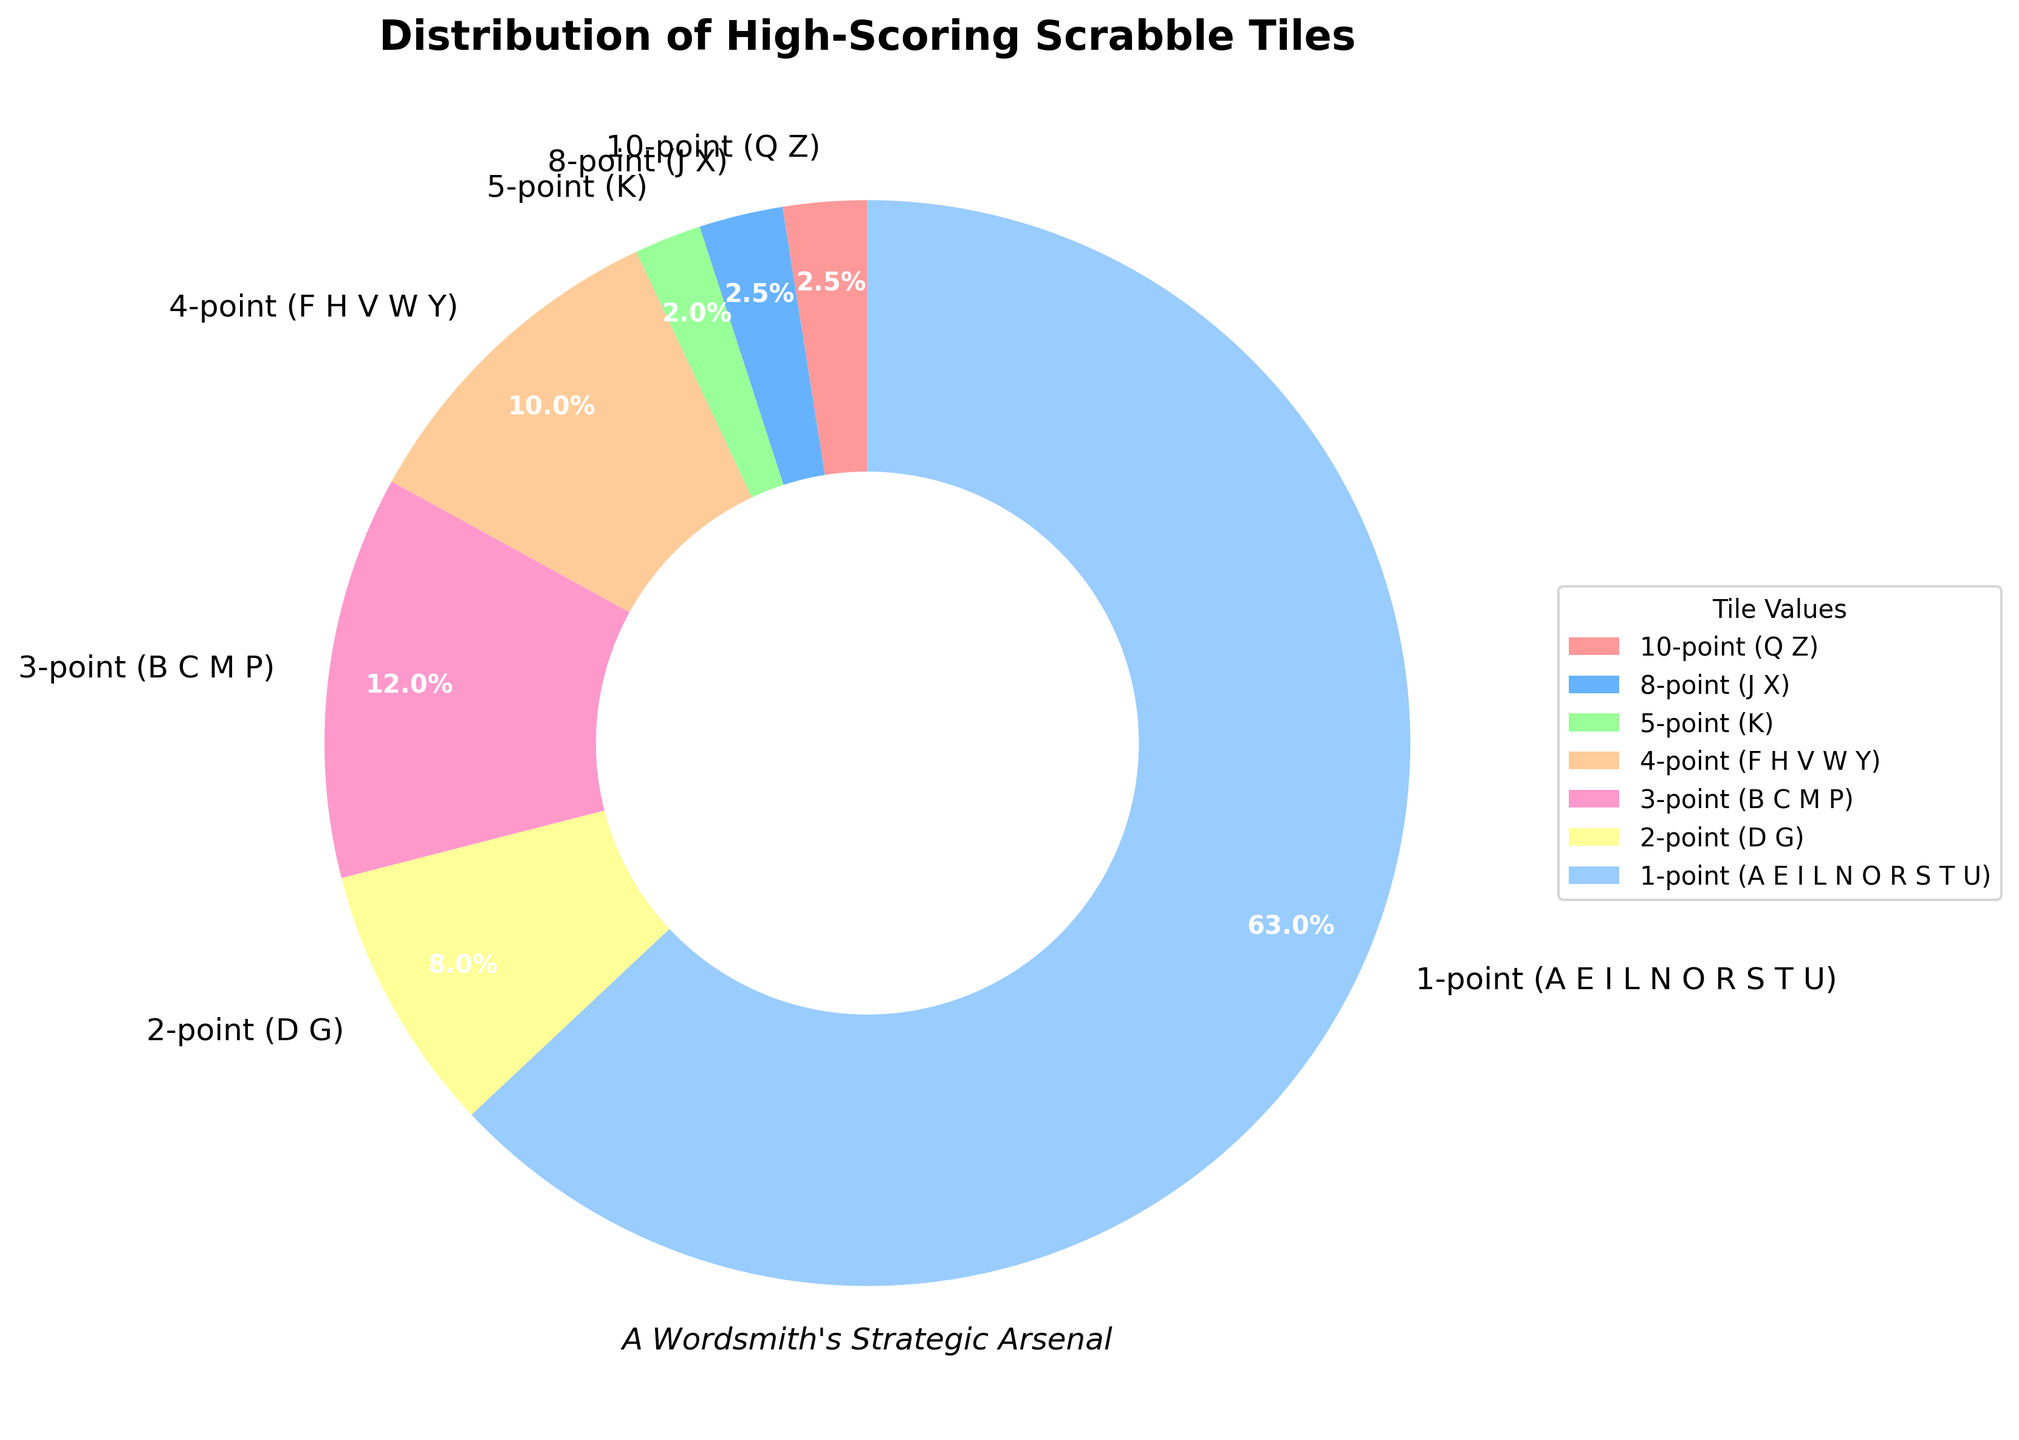What percentage of the tiles are worth 1 point? The 1-point tiles are labeled as "1-point (A E I L N O R S T U)" and the percentage given is directly visible in the pie chart segment
Answer: 63.0% What is the combined percentage of the 8-point and 10-point tiles? From the chart, the 8-point tiles have 2.5% and the 10-point tiles have 2.5%. Adding these together: 2.5% + 2.5%
Answer: 5.0% Which tile value group has the smallest percentage? The smallest percentage can be seen by looking at the legend and pie chart sections. Both the 10-point (Q Z) and 8-point (J X) tiles share the lowest percentage at 2.5% each
Answer: 10-point (Q Z) and 8-point (J X) How many tile value groups have a percentage that is higher than the 5-point tiles? The 5-point tiles have a percentage of 2.0%. Checking percentages higher than this: 4-point tiles (10%), 3-point tiles (12%), 2-point tiles (8%), 1-point tiles (63%) which are four groups
Answer: Four groups By how much does the percentage of 1-point tiles exceed the combined percentage of 2-point and 3-point tiles? 1-point tiles have 63.0%, 2-point tiles have 8.0%, and 3-point tiles have 12.0%. Combined percentage of 2-point and 3-point tiles is 8.0% + 12.0% = 20.0%. The difference is 63.0% - 20.0% = 43.0%
Answer: 43.0% Which tile value group is represented by the biggest wedge in the pie chart? Observing the wedges, the biggest wedge is distinctly the 1-point tiles, labeled "1-point (A E I L N O R S T U)" with 63%
Answer: 1-point (A E I L N O R S T U) What is the percentage difference between the 4-point tiles and the 5-point tiles? The chart shows 4-point tiles at 10.0% and 5-point tiles at 2.0%. The percentage difference is 10.0% - 2.0%
Answer: 8.0% If you combine the percentages of the 4-point and 5-point tiles, do they surpass the percentage of the 2-point tiles? 4-point tiles have 10.0% and 5-point tiles have 2.0%. Combined percentage: 10.0% + 2.0% = 12.0%. The 2-point tiles have 8.0%. 12.0% is greater than 8.0%
Answer: Yes Given the percentages of the high-scoring tiles, what strategy might a competitive Scrabble player employ? The 1-point tiles constitute the majority (63%), indicating their abundance. High-scoring tiles (8-point and 10-point) are scarce (2.5% each). This suggests a strategy focusing on creating numerous words with 1-point tiles while reserving high-point tiles for critical plays
Answer: Prioritize common 1-point tiles and strategically use rare high-point tiles 